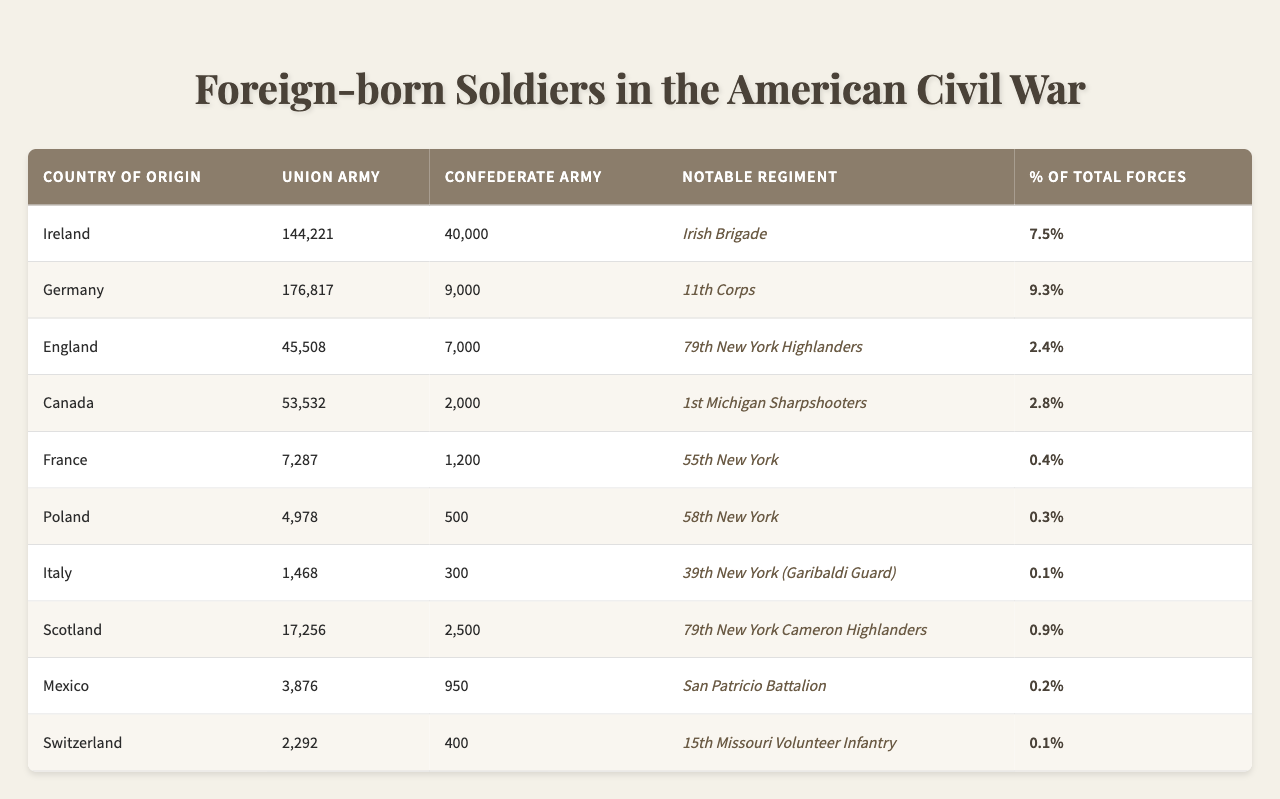What country contributed the most foreign-born soldiers to the Union Army? The table shows the number of foreign-born soldiers from each country who served in the Union Army. Ireland has the highest number with 144,221 soldiers.
Answer: Ireland How many foreign-born soldiers from Germany fought in the Confederate Army? The table lists 9,000 soldiers from Germany who served in the Confederate Army.
Answer: 9,000 What is the percentage of total forces contributed by Italian soldiers in the Union Army? The percentage of total forces contributed by Italian soldiers in the Union Army is given in the table as 0.1%.
Answer: 0.1% Which country has the lowest representation in the Confederate Army? By comparing the numbers in the Confederate Army column, Switzerland has the least number of soldiers at 400.
Answer: Switzerland What is the total number of foreign-born soldiers from Mexico and Canada in the Union Army? The total can be calculated by adding the numbers of foreign-born soldiers from Mexico (3,876) and Canada (53,532), which is 3,876 + 53,532 = 57,408.
Answer: 57,408 Did more foreign-born soldiers serve in the Union Army or the Confederate Army? A quick glance at the total numbers in both columns reveals that the Union Army had significantly more foreign-born soldiers (1,099,194) compared to the Confederate Army (104,300).
Answer: Union Army What is the difference between the number of foreign-born soldiers in the Union and Confederate armies from England? The table shows that 45,508 soldiers from England served in the Union Army and 7,000 in the Confederate Army. The difference is 45,508 - 7,000 = 38,508.
Answer: 38,508 Which notable regiment had foreign-born soldiers from Canada? The notable regiment listed in the table that included soldiers from Canada is the 1st Michigan Sharpshooters.
Answer: 1st Michigan Sharpshooters What percentage of total forces did the Irish Brigade represent? The percentage of total forces represented by the Irish Brigade, noted for Irish soldiers, is 7.5% according to the table.
Answer: 7.5% Which country's soldiers contributed to a notable regiment that fought for the Confederacy? The table indicates that Mexican soldiers contributed to the San Patricio Battalion, which fought for the Confederacy.
Answer: Mexico 